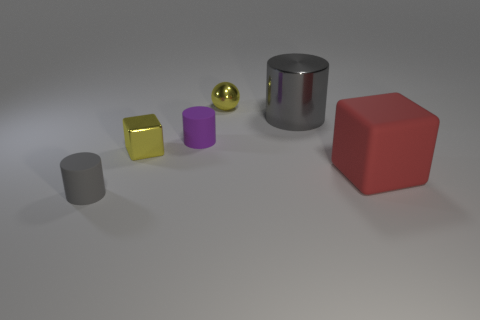What number of big cylinders are there?
Keep it short and to the point. 1. Do the yellow metal block and the red matte block have the same size?
Provide a short and direct response. No. Is there a tiny gray matte cylinder left of the tiny yellow metallic object behind the gray object right of the tiny yellow metal cube?
Make the answer very short. Yes. There is a purple thing that is the same shape as the gray shiny object; what is it made of?
Offer a very short reply. Rubber. The small rubber cylinder on the left side of the small metallic block is what color?
Make the answer very short. Gray. What is the size of the yellow shiny sphere?
Provide a succinct answer. Small. There is a gray shiny object; is it the same size as the thing to the right of the large gray cylinder?
Provide a succinct answer. Yes. There is a thing behind the gray thing behind the tiny cylinder in front of the big red matte block; what is its color?
Offer a terse response. Yellow. Does the yellow object on the left side of the tiny purple object have the same material as the tiny yellow ball?
Ensure brevity in your answer.  Yes. How many other objects are there of the same material as the big cube?
Ensure brevity in your answer.  2. 